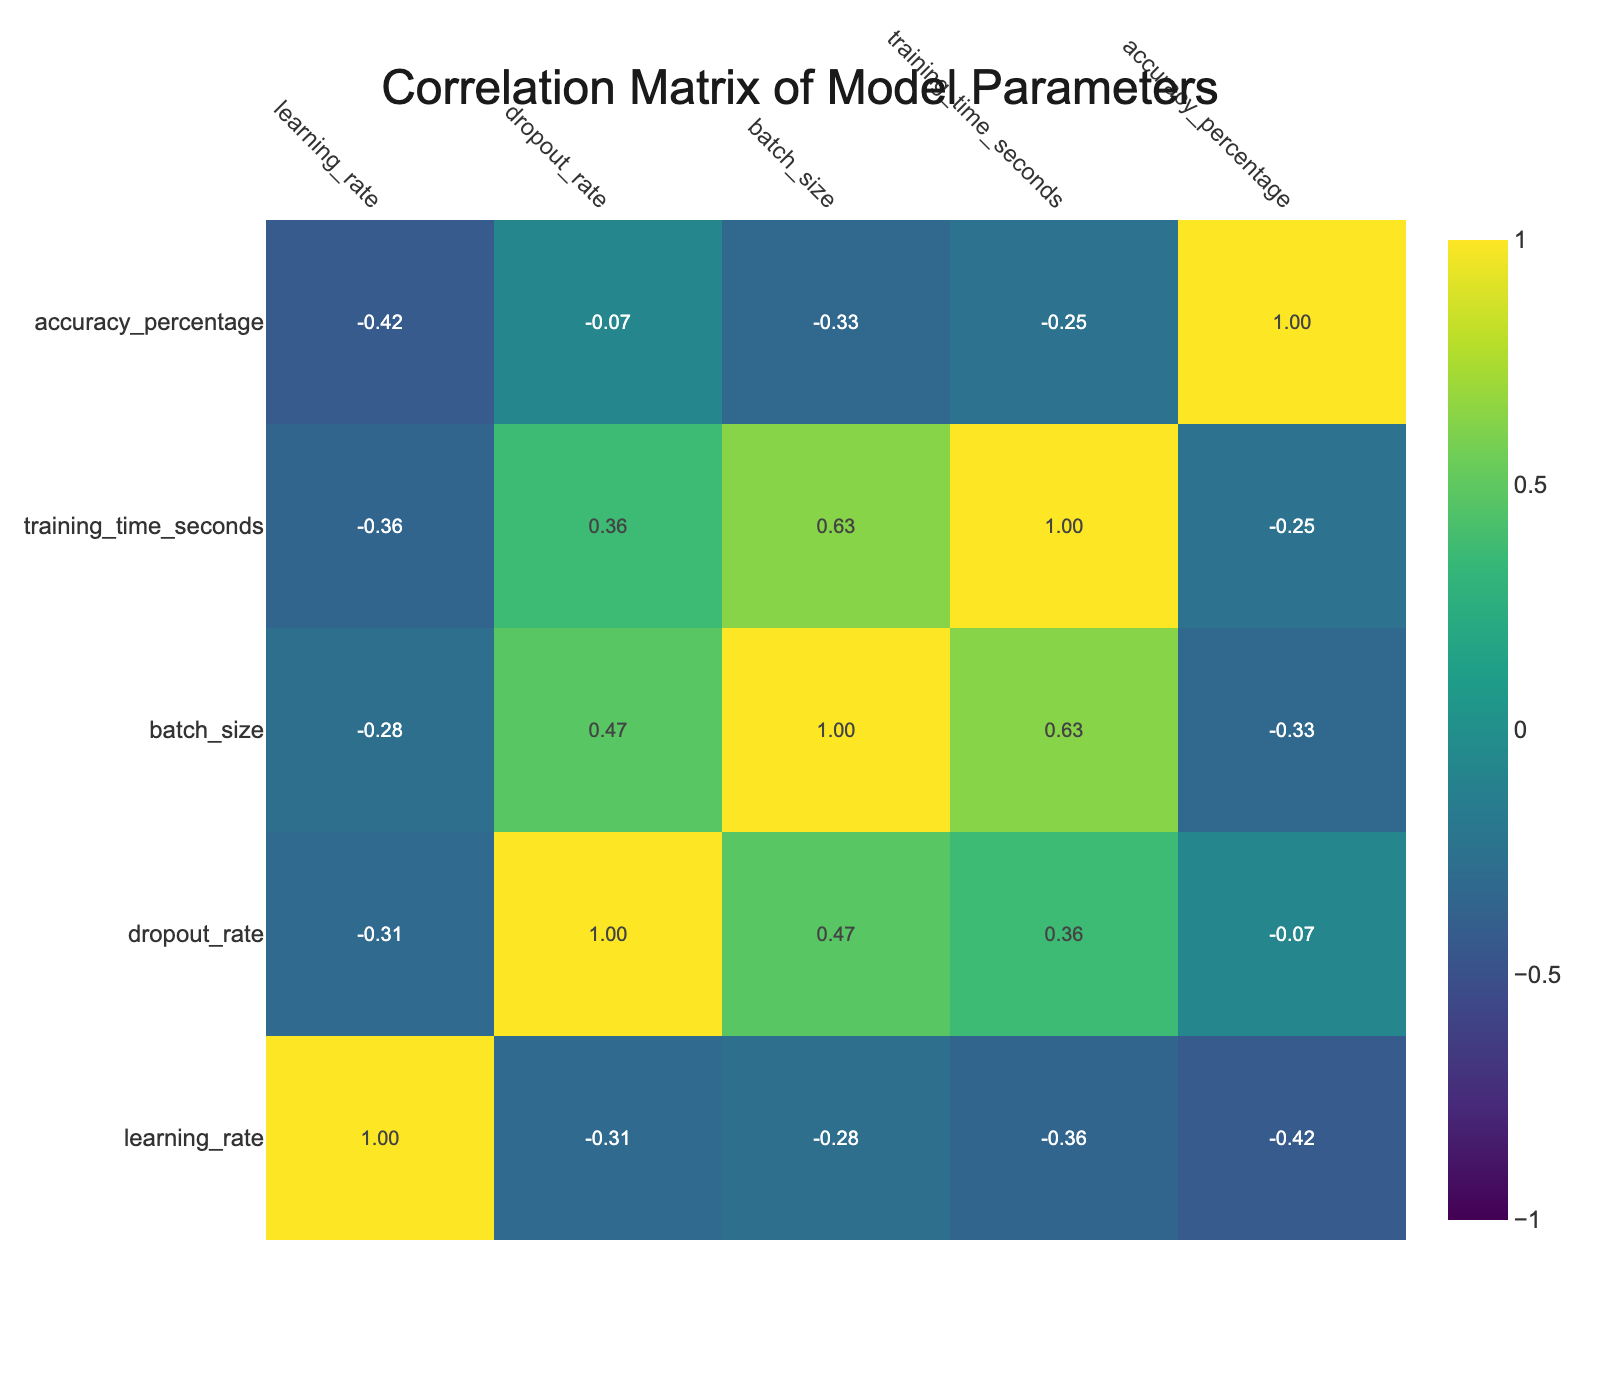What is the accuracy percentage of the CNN model with a learning rate of 0.001? The table shows that the CNN model with a learning rate of 0.001 has an accuracy percentage of 89.5.
Answer: 89.5 What is the training time in seconds for the RNN model with a dropout rate of 0.2 and batch size of 64? According to the table, the training time for the RNN model with these specifications is 2500 seconds.
Answer: 2500 Is the SVM model with a learning rate of 0.01 associated with an accuracy percentage greater than 85? The table indicates that the SVM model with a learning rate of 0.01 has an accuracy percentage of 88.4, which is greater than 85, thus the statement is true.
Answer: Yes What is the average training time for all models with a dropout rate of 0? To find the average training time for models with a dropout rate of 0, we consider the models: SVM (2000) and Decision Tree (1200). The average is (2000 + 1200) / 2 = 1600 seconds.
Answer: 1600 Which model type has the highest accuracy percentage, and what is that percentage? By analyzing the table, the CNN model with a learning rate of 0.001 has the highest accuracy percentage, which is 91.3.
Answer: CNN, 91.3 Is there a relationship between batch size and accuracy percentage for the Decision Tree model? Observing the Decision Tree entries, as the batch size increases from 16 to 64, the accuracy decreases from 80.3 to 77.9, indicating a negative relationship between the two variables for this model.
Answer: Yes What is the training time difference between the CNN model with a learning rate of 0.01 and the RNN model with a learning rate of 0.01? The training time for CNN with a learning rate of 0.01 is 3000 seconds, while for RNN with a learning rate of 0.01, it is 4000 seconds. The difference is 4000 - 3000 = 1000 seconds.
Answer: 1000 What is the maximum accuracy percentage among the models analyzed in the table? The maximum accuracy percentage is identified by examining all entries. The CNN model with a learning rate of 0.001 achieves the highest percentage at 91.3.
Answer: 91.3 What happens to accuracy percentages as learning rates increase across all models? Observing the table, a trend can be identified: as the learning rates increase (0.001 to 0.01), the accuracy percentages tend to decline in RNN and Decision Trees, while CNN maintains similar performance; this indicates a generally negative relationship for certain models.
Answer: Generally negative relationship 